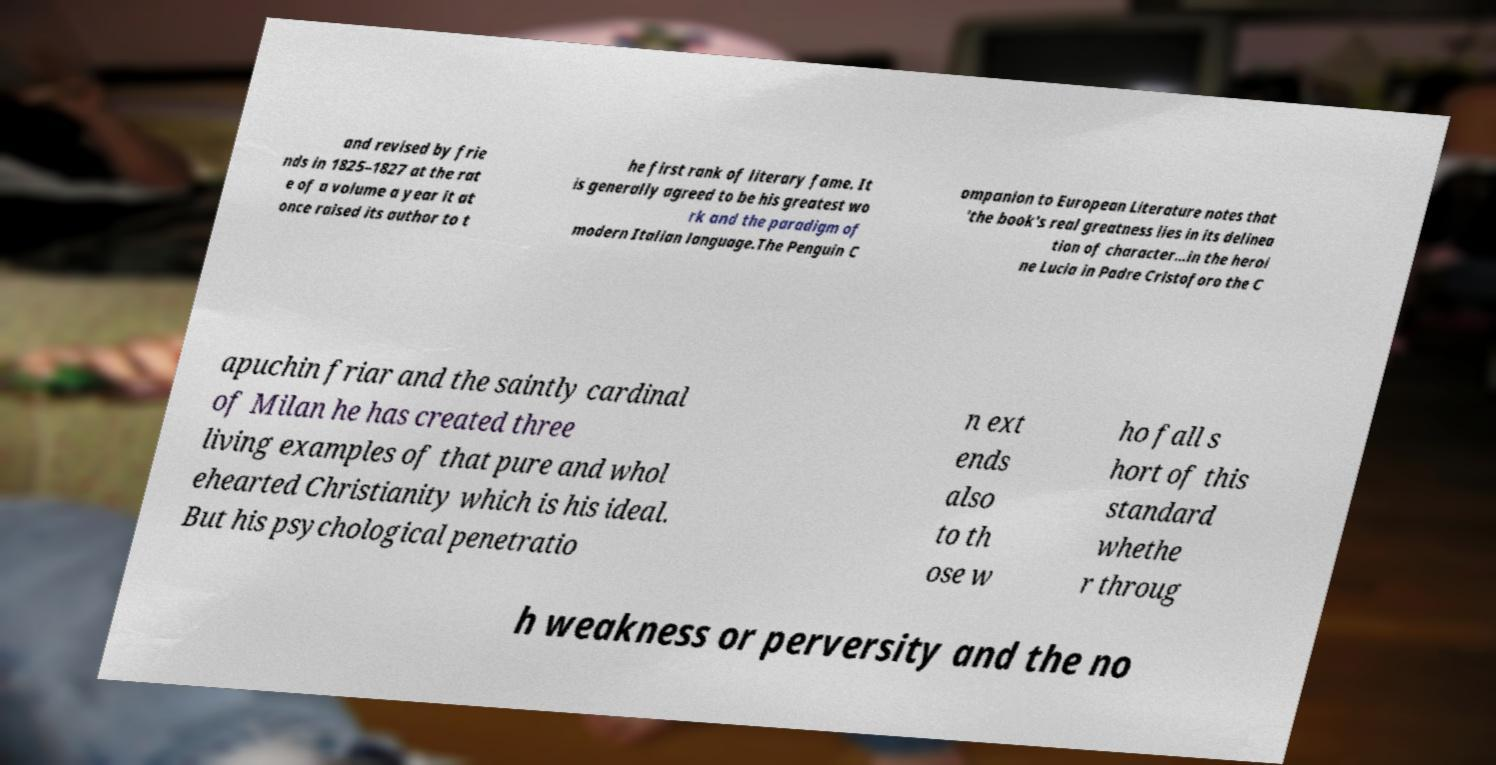Please identify and transcribe the text found in this image. and revised by frie nds in 1825–1827 at the rat e of a volume a year it at once raised its author to t he first rank of literary fame. It is generally agreed to be his greatest wo rk and the paradigm of modern Italian language.The Penguin C ompanion to European Literature notes that 'the book's real greatness lies in its delinea tion of character...in the heroi ne Lucia in Padre Cristoforo the C apuchin friar and the saintly cardinal of Milan he has created three living examples of that pure and whol ehearted Christianity which is his ideal. But his psychological penetratio n ext ends also to th ose w ho fall s hort of this standard whethe r throug h weakness or perversity and the no 